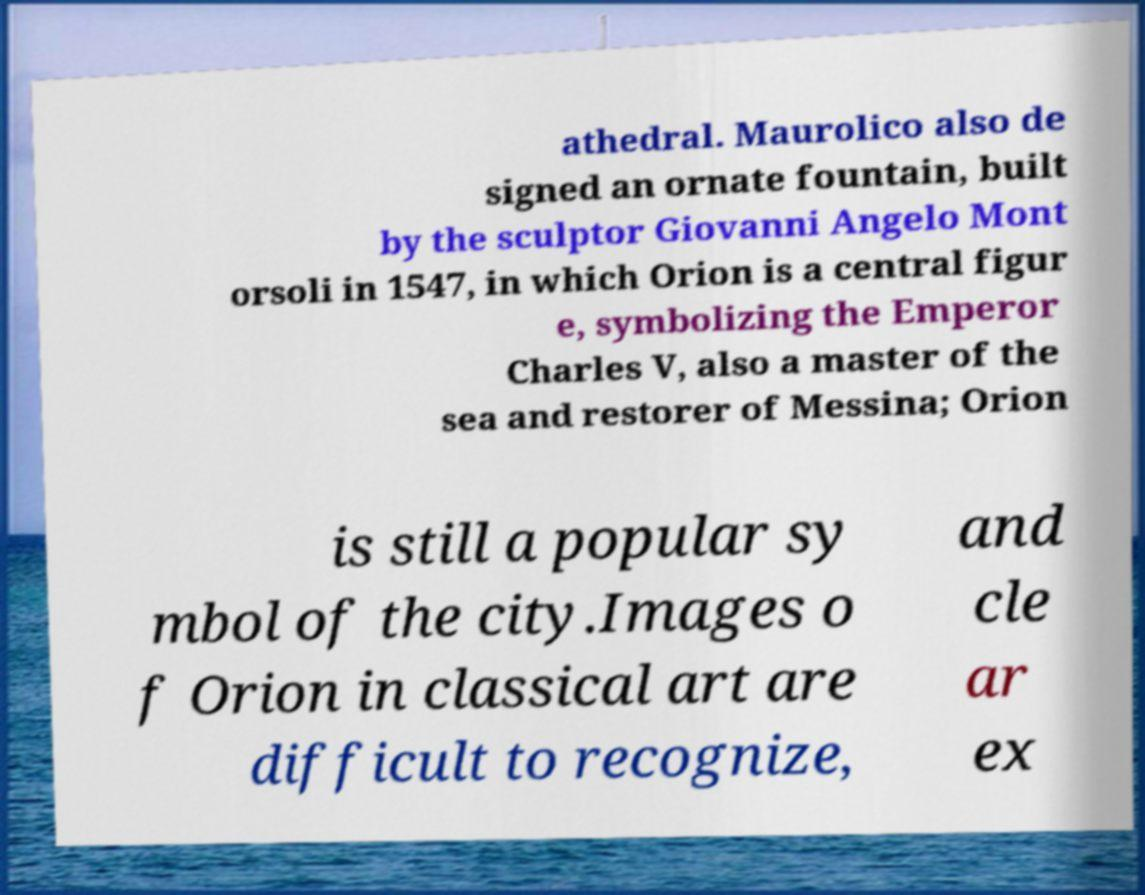I need the written content from this picture converted into text. Can you do that? athedral. Maurolico also de signed an ornate fountain, built by the sculptor Giovanni Angelo Mont orsoli in 1547, in which Orion is a central figur e, symbolizing the Emperor Charles V, also a master of the sea and restorer of Messina; Orion is still a popular sy mbol of the city.Images o f Orion in classical art are difficult to recognize, and cle ar ex 